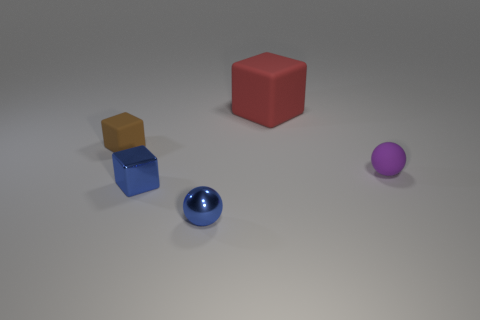Add 5 tiny blue cubes. How many objects exist? 10 Subtract all blocks. How many objects are left? 2 Add 2 small blue metal cubes. How many small blue metal cubes exist? 3 Subtract 0 yellow spheres. How many objects are left? 5 Subtract all small brown rubber blocks. Subtract all big shiny blocks. How many objects are left? 4 Add 2 tiny purple rubber balls. How many tiny purple rubber balls are left? 3 